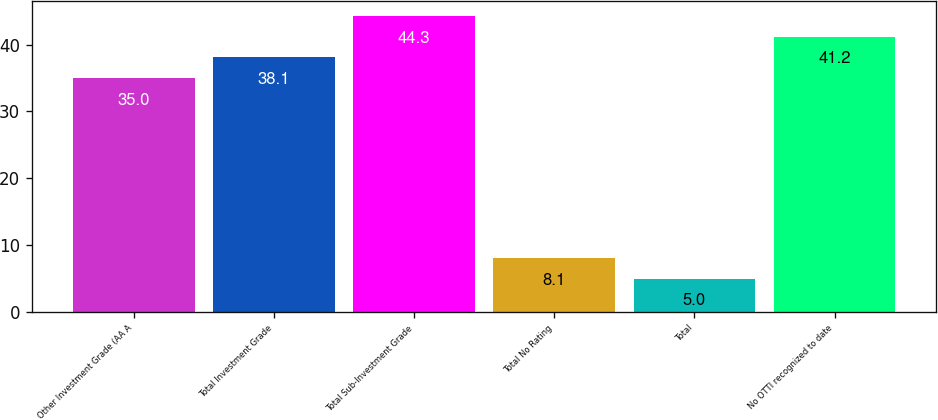<chart> <loc_0><loc_0><loc_500><loc_500><bar_chart><fcel>Other Investment Grade (AA A<fcel>Total Investment Grade<fcel>Total Sub-Investment Grade<fcel>Total No Rating<fcel>Total<fcel>No OTTI recognized to date<nl><fcel>35<fcel>38.1<fcel>44.3<fcel>8.1<fcel>5<fcel>41.2<nl></chart> 